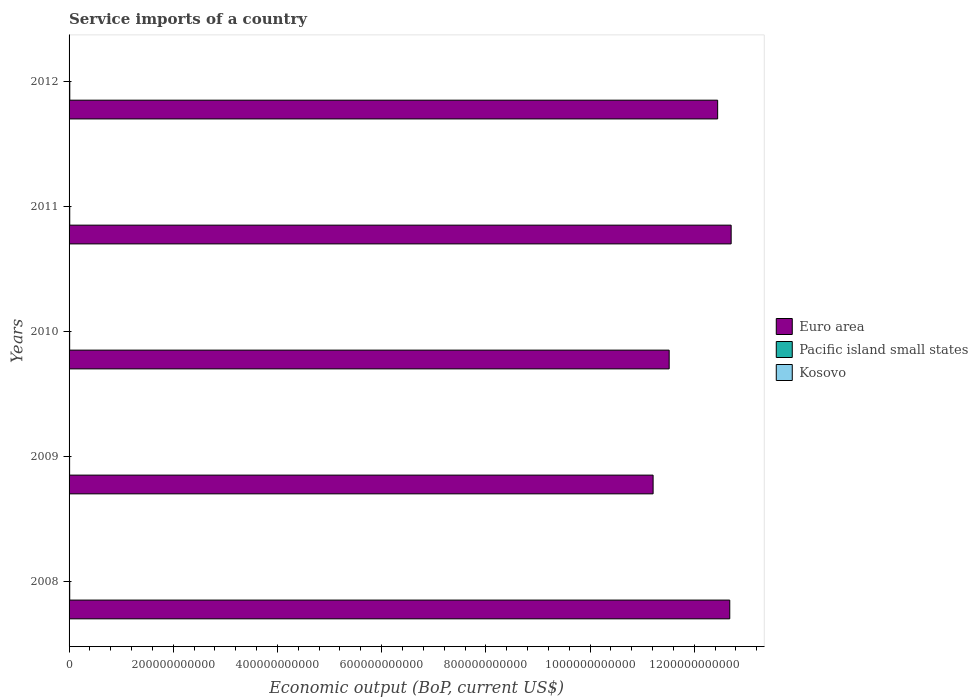How many groups of bars are there?
Give a very brief answer. 5. Are the number of bars per tick equal to the number of legend labels?
Keep it short and to the point. Yes. Are the number of bars on each tick of the Y-axis equal?
Ensure brevity in your answer.  Yes. How many bars are there on the 4th tick from the top?
Provide a succinct answer. 3. What is the service imports in Euro area in 2011?
Your answer should be very brief. 1.27e+12. Across all years, what is the maximum service imports in Pacific island small states?
Offer a very short reply. 1.36e+09. Across all years, what is the minimum service imports in Pacific island small states?
Ensure brevity in your answer.  1.04e+09. In which year was the service imports in Pacific island small states maximum?
Your answer should be very brief. 2012. What is the total service imports in Euro area in the graph?
Offer a very short reply. 6.06e+12. What is the difference between the service imports in Pacific island small states in 2008 and that in 2011?
Your answer should be very brief. -2.08e+07. What is the difference between the service imports in Pacific island small states in 2011 and the service imports in Kosovo in 2008?
Provide a short and direct response. 8.66e+08. What is the average service imports in Pacific island small states per year?
Provide a succinct answer. 1.21e+09. In the year 2012, what is the difference between the service imports in Kosovo and service imports in Pacific island small states?
Your response must be concise. -9.51e+08. In how many years, is the service imports in Kosovo greater than 880000000000 US$?
Your response must be concise. 0. What is the ratio of the service imports in Euro area in 2008 to that in 2011?
Give a very brief answer. 1. What is the difference between the highest and the second highest service imports in Pacific island small states?
Provide a short and direct response. 8.54e+07. What is the difference between the highest and the lowest service imports in Pacific island small states?
Offer a terse response. 3.15e+08. In how many years, is the service imports in Kosovo greater than the average service imports in Kosovo taken over all years?
Offer a terse response. 2. What does the 3rd bar from the top in 2008 represents?
Your response must be concise. Euro area. What does the 3rd bar from the bottom in 2012 represents?
Your answer should be very brief. Kosovo. Is it the case that in every year, the sum of the service imports in Kosovo and service imports in Pacific island small states is greater than the service imports in Euro area?
Your answer should be very brief. No. How many years are there in the graph?
Ensure brevity in your answer.  5. What is the difference between two consecutive major ticks on the X-axis?
Offer a terse response. 2.00e+11. Does the graph contain grids?
Provide a short and direct response. No. Where does the legend appear in the graph?
Provide a succinct answer. Center right. How many legend labels are there?
Give a very brief answer. 3. How are the legend labels stacked?
Offer a terse response. Vertical. What is the title of the graph?
Provide a succinct answer. Service imports of a country. Does "Thailand" appear as one of the legend labels in the graph?
Your answer should be compact. No. What is the label or title of the X-axis?
Provide a succinct answer. Economic output (BoP, current US$). What is the Economic output (BoP, current US$) of Euro area in 2008?
Provide a succinct answer. 1.27e+12. What is the Economic output (BoP, current US$) in Pacific island small states in 2008?
Keep it short and to the point. 1.25e+09. What is the Economic output (BoP, current US$) in Kosovo in 2008?
Keep it short and to the point. 4.06e+08. What is the Economic output (BoP, current US$) in Euro area in 2009?
Offer a terse response. 1.12e+12. What is the Economic output (BoP, current US$) in Pacific island small states in 2009?
Keep it short and to the point. 1.04e+09. What is the Economic output (BoP, current US$) of Kosovo in 2009?
Give a very brief answer. 4.12e+08. What is the Economic output (BoP, current US$) of Euro area in 2010?
Ensure brevity in your answer.  1.15e+12. What is the Economic output (BoP, current US$) of Pacific island small states in 2010?
Make the answer very short. 1.12e+09. What is the Economic output (BoP, current US$) of Kosovo in 2010?
Provide a short and direct response. 5.28e+08. What is the Economic output (BoP, current US$) of Euro area in 2011?
Offer a very short reply. 1.27e+12. What is the Economic output (BoP, current US$) of Pacific island small states in 2011?
Offer a terse response. 1.27e+09. What is the Economic output (BoP, current US$) in Kosovo in 2011?
Your answer should be compact. 5.36e+08. What is the Economic output (BoP, current US$) of Euro area in 2012?
Keep it short and to the point. 1.24e+12. What is the Economic output (BoP, current US$) of Pacific island small states in 2012?
Ensure brevity in your answer.  1.36e+09. What is the Economic output (BoP, current US$) in Kosovo in 2012?
Your response must be concise. 4.07e+08. Across all years, what is the maximum Economic output (BoP, current US$) of Euro area?
Provide a succinct answer. 1.27e+12. Across all years, what is the maximum Economic output (BoP, current US$) in Pacific island small states?
Offer a terse response. 1.36e+09. Across all years, what is the maximum Economic output (BoP, current US$) of Kosovo?
Your answer should be compact. 5.36e+08. Across all years, what is the minimum Economic output (BoP, current US$) of Euro area?
Make the answer very short. 1.12e+12. Across all years, what is the minimum Economic output (BoP, current US$) of Pacific island small states?
Offer a terse response. 1.04e+09. Across all years, what is the minimum Economic output (BoP, current US$) of Kosovo?
Your answer should be compact. 4.06e+08. What is the total Economic output (BoP, current US$) in Euro area in the graph?
Keep it short and to the point. 6.06e+12. What is the total Economic output (BoP, current US$) in Pacific island small states in the graph?
Give a very brief answer. 6.04e+09. What is the total Economic output (BoP, current US$) in Kosovo in the graph?
Your response must be concise. 2.29e+09. What is the difference between the Economic output (BoP, current US$) of Euro area in 2008 and that in 2009?
Offer a terse response. 1.47e+11. What is the difference between the Economic output (BoP, current US$) of Pacific island small states in 2008 and that in 2009?
Make the answer very short. 2.09e+08. What is the difference between the Economic output (BoP, current US$) of Kosovo in 2008 and that in 2009?
Provide a succinct answer. -6.34e+06. What is the difference between the Economic output (BoP, current US$) in Euro area in 2008 and that in 2010?
Your response must be concise. 1.16e+11. What is the difference between the Economic output (BoP, current US$) in Pacific island small states in 2008 and that in 2010?
Ensure brevity in your answer.  1.35e+08. What is the difference between the Economic output (BoP, current US$) of Kosovo in 2008 and that in 2010?
Offer a very short reply. -1.22e+08. What is the difference between the Economic output (BoP, current US$) in Euro area in 2008 and that in 2011?
Offer a very short reply. -2.66e+09. What is the difference between the Economic output (BoP, current US$) in Pacific island small states in 2008 and that in 2011?
Your answer should be very brief. -2.08e+07. What is the difference between the Economic output (BoP, current US$) in Kosovo in 2008 and that in 2011?
Offer a terse response. -1.30e+08. What is the difference between the Economic output (BoP, current US$) in Euro area in 2008 and that in 2012?
Provide a succinct answer. 2.32e+1. What is the difference between the Economic output (BoP, current US$) in Pacific island small states in 2008 and that in 2012?
Provide a succinct answer. -1.06e+08. What is the difference between the Economic output (BoP, current US$) of Kosovo in 2008 and that in 2012?
Offer a terse response. -9.33e+05. What is the difference between the Economic output (BoP, current US$) in Euro area in 2009 and that in 2010?
Give a very brief answer. -3.08e+1. What is the difference between the Economic output (BoP, current US$) of Pacific island small states in 2009 and that in 2010?
Give a very brief answer. -7.35e+07. What is the difference between the Economic output (BoP, current US$) in Kosovo in 2009 and that in 2010?
Your answer should be very brief. -1.16e+08. What is the difference between the Economic output (BoP, current US$) in Euro area in 2009 and that in 2011?
Give a very brief answer. -1.50e+11. What is the difference between the Economic output (BoP, current US$) of Pacific island small states in 2009 and that in 2011?
Offer a terse response. -2.29e+08. What is the difference between the Economic output (BoP, current US$) of Kosovo in 2009 and that in 2011?
Your response must be concise. -1.23e+08. What is the difference between the Economic output (BoP, current US$) of Euro area in 2009 and that in 2012?
Make the answer very short. -1.24e+11. What is the difference between the Economic output (BoP, current US$) in Pacific island small states in 2009 and that in 2012?
Provide a succinct answer. -3.15e+08. What is the difference between the Economic output (BoP, current US$) in Kosovo in 2009 and that in 2012?
Keep it short and to the point. 5.41e+06. What is the difference between the Economic output (BoP, current US$) of Euro area in 2010 and that in 2011?
Make the answer very short. -1.19e+11. What is the difference between the Economic output (BoP, current US$) in Pacific island small states in 2010 and that in 2011?
Your response must be concise. -1.56e+08. What is the difference between the Economic output (BoP, current US$) of Kosovo in 2010 and that in 2011?
Offer a terse response. -7.66e+06. What is the difference between the Economic output (BoP, current US$) in Euro area in 2010 and that in 2012?
Your response must be concise. -9.31e+1. What is the difference between the Economic output (BoP, current US$) in Pacific island small states in 2010 and that in 2012?
Make the answer very short. -2.41e+08. What is the difference between the Economic output (BoP, current US$) in Kosovo in 2010 and that in 2012?
Your answer should be compact. 1.21e+08. What is the difference between the Economic output (BoP, current US$) of Euro area in 2011 and that in 2012?
Your answer should be very brief. 2.59e+1. What is the difference between the Economic output (BoP, current US$) in Pacific island small states in 2011 and that in 2012?
Offer a terse response. -8.54e+07. What is the difference between the Economic output (BoP, current US$) of Kosovo in 2011 and that in 2012?
Provide a succinct answer. 1.29e+08. What is the difference between the Economic output (BoP, current US$) in Euro area in 2008 and the Economic output (BoP, current US$) in Pacific island small states in 2009?
Ensure brevity in your answer.  1.27e+12. What is the difference between the Economic output (BoP, current US$) in Euro area in 2008 and the Economic output (BoP, current US$) in Kosovo in 2009?
Provide a succinct answer. 1.27e+12. What is the difference between the Economic output (BoP, current US$) in Pacific island small states in 2008 and the Economic output (BoP, current US$) in Kosovo in 2009?
Provide a succinct answer. 8.39e+08. What is the difference between the Economic output (BoP, current US$) of Euro area in 2008 and the Economic output (BoP, current US$) of Pacific island small states in 2010?
Your answer should be very brief. 1.27e+12. What is the difference between the Economic output (BoP, current US$) of Euro area in 2008 and the Economic output (BoP, current US$) of Kosovo in 2010?
Keep it short and to the point. 1.27e+12. What is the difference between the Economic output (BoP, current US$) of Pacific island small states in 2008 and the Economic output (BoP, current US$) of Kosovo in 2010?
Your answer should be very brief. 7.24e+08. What is the difference between the Economic output (BoP, current US$) of Euro area in 2008 and the Economic output (BoP, current US$) of Pacific island small states in 2011?
Keep it short and to the point. 1.27e+12. What is the difference between the Economic output (BoP, current US$) in Euro area in 2008 and the Economic output (BoP, current US$) in Kosovo in 2011?
Your answer should be compact. 1.27e+12. What is the difference between the Economic output (BoP, current US$) in Pacific island small states in 2008 and the Economic output (BoP, current US$) in Kosovo in 2011?
Make the answer very short. 7.16e+08. What is the difference between the Economic output (BoP, current US$) of Euro area in 2008 and the Economic output (BoP, current US$) of Pacific island small states in 2012?
Offer a terse response. 1.27e+12. What is the difference between the Economic output (BoP, current US$) of Euro area in 2008 and the Economic output (BoP, current US$) of Kosovo in 2012?
Your answer should be compact. 1.27e+12. What is the difference between the Economic output (BoP, current US$) of Pacific island small states in 2008 and the Economic output (BoP, current US$) of Kosovo in 2012?
Your answer should be very brief. 8.45e+08. What is the difference between the Economic output (BoP, current US$) of Euro area in 2009 and the Economic output (BoP, current US$) of Pacific island small states in 2010?
Give a very brief answer. 1.12e+12. What is the difference between the Economic output (BoP, current US$) in Euro area in 2009 and the Economic output (BoP, current US$) in Kosovo in 2010?
Give a very brief answer. 1.12e+12. What is the difference between the Economic output (BoP, current US$) in Pacific island small states in 2009 and the Economic output (BoP, current US$) in Kosovo in 2010?
Offer a terse response. 5.15e+08. What is the difference between the Economic output (BoP, current US$) in Euro area in 2009 and the Economic output (BoP, current US$) in Pacific island small states in 2011?
Make the answer very short. 1.12e+12. What is the difference between the Economic output (BoP, current US$) in Euro area in 2009 and the Economic output (BoP, current US$) in Kosovo in 2011?
Keep it short and to the point. 1.12e+12. What is the difference between the Economic output (BoP, current US$) of Pacific island small states in 2009 and the Economic output (BoP, current US$) of Kosovo in 2011?
Make the answer very short. 5.07e+08. What is the difference between the Economic output (BoP, current US$) of Euro area in 2009 and the Economic output (BoP, current US$) of Pacific island small states in 2012?
Provide a short and direct response. 1.12e+12. What is the difference between the Economic output (BoP, current US$) of Euro area in 2009 and the Economic output (BoP, current US$) of Kosovo in 2012?
Ensure brevity in your answer.  1.12e+12. What is the difference between the Economic output (BoP, current US$) in Pacific island small states in 2009 and the Economic output (BoP, current US$) in Kosovo in 2012?
Your answer should be very brief. 6.36e+08. What is the difference between the Economic output (BoP, current US$) in Euro area in 2010 and the Economic output (BoP, current US$) in Pacific island small states in 2011?
Ensure brevity in your answer.  1.15e+12. What is the difference between the Economic output (BoP, current US$) of Euro area in 2010 and the Economic output (BoP, current US$) of Kosovo in 2011?
Provide a succinct answer. 1.15e+12. What is the difference between the Economic output (BoP, current US$) of Pacific island small states in 2010 and the Economic output (BoP, current US$) of Kosovo in 2011?
Provide a succinct answer. 5.81e+08. What is the difference between the Economic output (BoP, current US$) in Euro area in 2010 and the Economic output (BoP, current US$) in Pacific island small states in 2012?
Your answer should be very brief. 1.15e+12. What is the difference between the Economic output (BoP, current US$) in Euro area in 2010 and the Economic output (BoP, current US$) in Kosovo in 2012?
Provide a short and direct response. 1.15e+12. What is the difference between the Economic output (BoP, current US$) of Pacific island small states in 2010 and the Economic output (BoP, current US$) of Kosovo in 2012?
Offer a very short reply. 7.09e+08. What is the difference between the Economic output (BoP, current US$) of Euro area in 2011 and the Economic output (BoP, current US$) of Pacific island small states in 2012?
Offer a terse response. 1.27e+12. What is the difference between the Economic output (BoP, current US$) in Euro area in 2011 and the Economic output (BoP, current US$) in Kosovo in 2012?
Your response must be concise. 1.27e+12. What is the difference between the Economic output (BoP, current US$) in Pacific island small states in 2011 and the Economic output (BoP, current US$) in Kosovo in 2012?
Provide a short and direct response. 8.65e+08. What is the average Economic output (BoP, current US$) in Euro area per year?
Give a very brief answer. 1.21e+12. What is the average Economic output (BoP, current US$) of Pacific island small states per year?
Provide a succinct answer. 1.21e+09. What is the average Economic output (BoP, current US$) of Kosovo per year?
Provide a succinct answer. 4.58e+08. In the year 2008, what is the difference between the Economic output (BoP, current US$) of Euro area and Economic output (BoP, current US$) of Pacific island small states?
Offer a terse response. 1.27e+12. In the year 2008, what is the difference between the Economic output (BoP, current US$) of Euro area and Economic output (BoP, current US$) of Kosovo?
Your answer should be very brief. 1.27e+12. In the year 2008, what is the difference between the Economic output (BoP, current US$) in Pacific island small states and Economic output (BoP, current US$) in Kosovo?
Offer a terse response. 8.45e+08. In the year 2009, what is the difference between the Economic output (BoP, current US$) in Euro area and Economic output (BoP, current US$) in Pacific island small states?
Give a very brief answer. 1.12e+12. In the year 2009, what is the difference between the Economic output (BoP, current US$) in Euro area and Economic output (BoP, current US$) in Kosovo?
Provide a short and direct response. 1.12e+12. In the year 2009, what is the difference between the Economic output (BoP, current US$) of Pacific island small states and Economic output (BoP, current US$) of Kosovo?
Ensure brevity in your answer.  6.31e+08. In the year 2010, what is the difference between the Economic output (BoP, current US$) in Euro area and Economic output (BoP, current US$) in Pacific island small states?
Offer a terse response. 1.15e+12. In the year 2010, what is the difference between the Economic output (BoP, current US$) in Euro area and Economic output (BoP, current US$) in Kosovo?
Keep it short and to the point. 1.15e+12. In the year 2010, what is the difference between the Economic output (BoP, current US$) of Pacific island small states and Economic output (BoP, current US$) of Kosovo?
Provide a short and direct response. 5.88e+08. In the year 2011, what is the difference between the Economic output (BoP, current US$) in Euro area and Economic output (BoP, current US$) in Pacific island small states?
Provide a succinct answer. 1.27e+12. In the year 2011, what is the difference between the Economic output (BoP, current US$) in Euro area and Economic output (BoP, current US$) in Kosovo?
Offer a very short reply. 1.27e+12. In the year 2011, what is the difference between the Economic output (BoP, current US$) of Pacific island small states and Economic output (BoP, current US$) of Kosovo?
Offer a terse response. 7.37e+08. In the year 2012, what is the difference between the Economic output (BoP, current US$) in Euro area and Economic output (BoP, current US$) in Pacific island small states?
Ensure brevity in your answer.  1.24e+12. In the year 2012, what is the difference between the Economic output (BoP, current US$) of Euro area and Economic output (BoP, current US$) of Kosovo?
Make the answer very short. 1.24e+12. In the year 2012, what is the difference between the Economic output (BoP, current US$) of Pacific island small states and Economic output (BoP, current US$) of Kosovo?
Make the answer very short. 9.51e+08. What is the ratio of the Economic output (BoP, current US$) in Euro area in 2008 to that in 2009?
Offer a terse response. 1.13. What is the ratio of the Economic output (BoP, current US$) of Pacific island small states in 2008 to that in 2009?
Your response must be concise. 1.2. What is the ratio of the Economic output (BoP, current US$) in Kosovo in 2008 to that in 2009?
Provide a succinct answer. 0.98. What is the ratio of the Economic output (BoP, current US$) of Euro area in 2008 to that in 2010?
Provide a short and direct response. 1.1. What is the ratio of the Economic output (BoP, current US$) in Pacific island small states in 2008 to that in 2010?
Your response must be concise. 1.12. What is the ratio of the Economic output (BoP, current US$) in Kosovo in 2008 to that in 2010?
Provide a short and direct response. 0.77. What is the ratio of the Economic output (BoP, current US$) in Pacific island small states in 2008 to that in 2011?
Offer a very short reply. 0.98. What is the ratio of the Economic output (BoP, current US$) in Kosovo in 2008 to that in 2011?
Your answer should be very brief. 0.76. What is the ratio of the Economic output (BoP, current US$) in Euro area in 2008 to that in 2012?
Make the answer very short. 1.02. What is the ratio of the Economic output (BoP, current US$) in Pacific island small states in 2008 to that in 2012?
Give a very brief answer. 0.92. What is the ratio of the Economic output (BoP, current US$) in Kosovo in 2008 to that in 2012?
Your answer should be compact. 1. What is the ratio of the Economic output (BoP, current US$) of Euro area in 2009 to that in 2010?
Make the answer very short. 0.97. What is the ratio of the Economic output (BoP, current US$) of Pacific island small states in 2009 to that in 2010?
Your answer should be very brief. 0.93. What is the ratio of the Economic output (BoP, current US$) in Kosovo in 2009 to that in 2010?
Your response must be concise. 0.78. What is the ratio of the Economic output (BoP, current US$) in Euro area in 2009 to that in 2011?
Your answer should be very brief. 0.88. What is the ratio of the Economic output (BoP, current US$) in Pacific island small states in 2009 to that in 2011?
Your response must be concise. 0.82. What is the ratio of the Economic output (BoP, current US$) in Kosovo in 2009 to that in 2011?
Your answer should be compact. 0.77. What is the ratio of the Economic output (BoP, current US$) of Euro area in 2009 to that in 2012?
Offer a terse response. 0.9. What is the ratio of the Economic output (BoP, current US$) of Pacific island small states in 2009 to that in 2012?
Provide a succinct answer. 0.77. What is the ratio of the Economic output (BoP, current US$) of Kosovo in 2009 to that in 2012?
Ensure brevity in your answer.  1.01. What is the ratio of the Economic output (BoP, current US$) in Euro area in 2010 to that in 2011?
Offer a terse response. 0.91. What is the ratio of the Economic output (BoP, current US$) in Pacific island small states in 2010 to that in 2011?
Provide a short and direct response. 0.88. What is the ratio of the Economic output (BoP, current US$) of Kosovo in 2010 to that in 2011?
Offer a very short reply. 0.99. What is the ratio of the Economic output (BoP, current US$) of Euro area in 2010 to that in 2012?
Keep it short and to the point. 0.93. What is the ratio of the Economic output (BoP, current US$) in Pacific island small states in 2010 to that in 2012?
Offer a very short reply. 0.82. What is the ratio of the Economic output (BoP, current US$) of Kosovo in 2010 to that in 2012?
Make the answer very short. 1.3. What is the ratio of the Economic output (BoP, current US$) of Euro area in 2011 to that in 2012?
Give a very brief answer. 1.02. What is the ratio of the Economic output (BoP, current US$) of Pacific island small states in 2011 to that in 2012?
Your response must be concise. 0.94. What is the ratio of the Economic output (BoP, current US$) in Kosovo in 2011 to that in 2012?
Give a very brief answer. 1.32. What is the difference between the highest and the second highest Economic output (BoP, current US$) of Euro area?
Your answer should be very brief. 2.66e+09. What is the difference between the highest and the second highest Economic output (BoP, current US$) of Pacific island small states?
Your answer should be compact. 8.54e+07. What is the difference between the highest and the second highest Economic output (BoP, current US$) in Kosovo?
Offer a terse response. 7.66e+06. What is the difference between the highest and the lowest Economic output (BoP, current US$) in Euro area?
Give a very brief answer. 1.50e+11. What is the difference between the highest and the lowest Economic output (BoP, current US$) in Pacific island small states?
Your response must be concise. 3.15e+08. What is the difference between the highest and the lowest Economic output (BoP, current US$) of Kosovo?
Ensure brevity in your answer.  1.30e+08. 